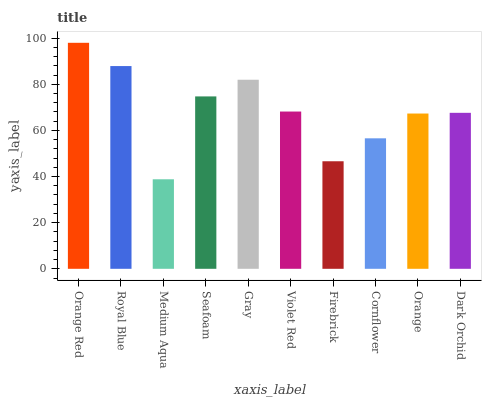Is Medium Aqua the minimum?
Answer yes or no. Yes. Is Orange Red the maximum?
Answer yes or no. Yes. Is Royal Blue the minimum?
Answer yes or no. No. Is Royal Blue the maximum?
Answer yes or no. No. Is Orange Red greater than Royal Blue?
Answer yes or no. Yes. Is Royal Blue less than Orange Red?
Answer yes or no. Yes. Is Royal Blue greater than Orange Red?
Answer yes or no. No. Is Orange Red less than Royal Blue?
Answer yes or no. No. Is Violet Red the high median?
Answer yes or no. Yes. Is Dark Orchid the low median?
Answer yes or no. Yes. Is Gray the high median?
Answer yes or no. No. Is Medium Aqua the low median?
Answer yes or no. No. 